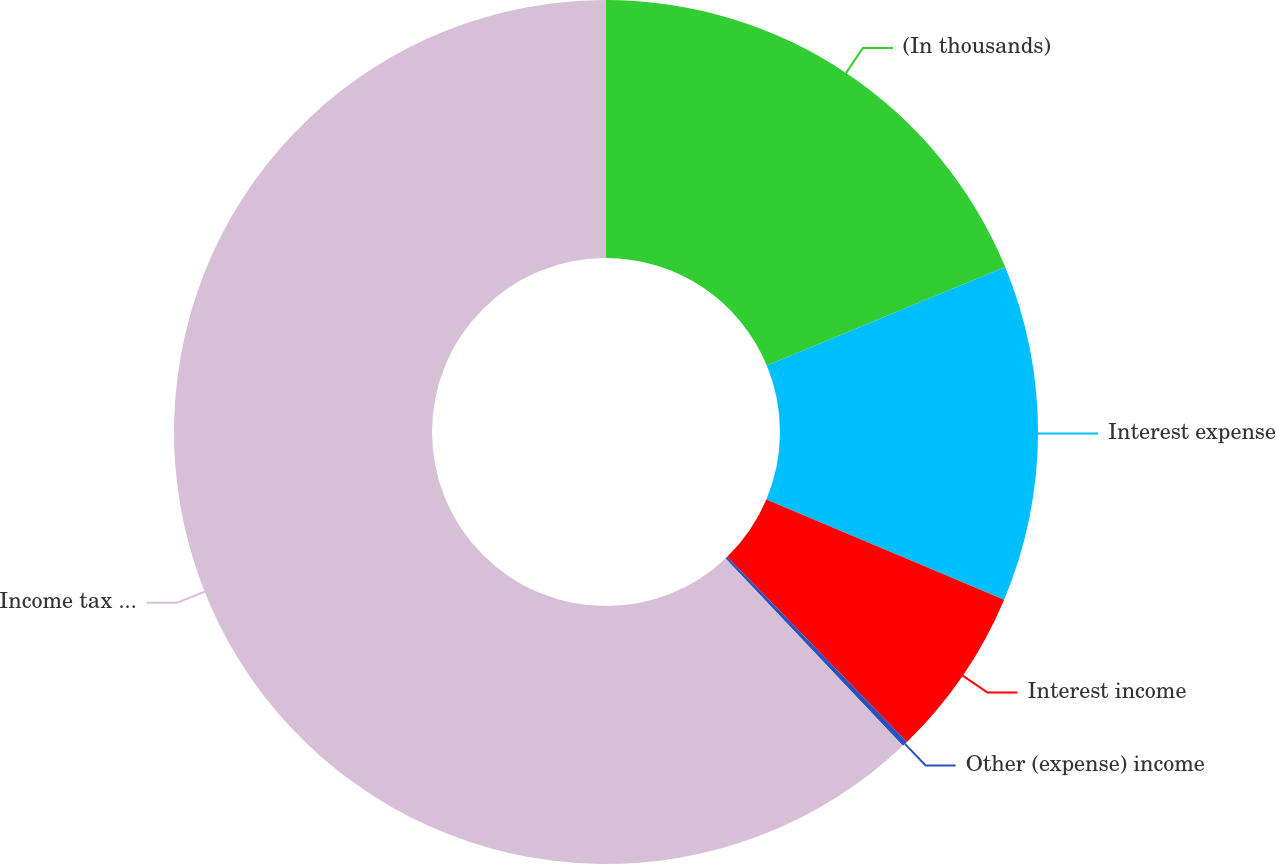<chart> <loc_0><loc_0><loc_500><loc_500><pie_chart><fcel>(In thousands)<fcel>Interest expense<fcel>Interest income<fcel>Other (expense) income<fcel>Income tax (expense) benefit<nl><fcel>18.76%<fcel>12.58%<fcel>6.39%<fcel>0.21%<fcel>62.05%<nl></chart> 